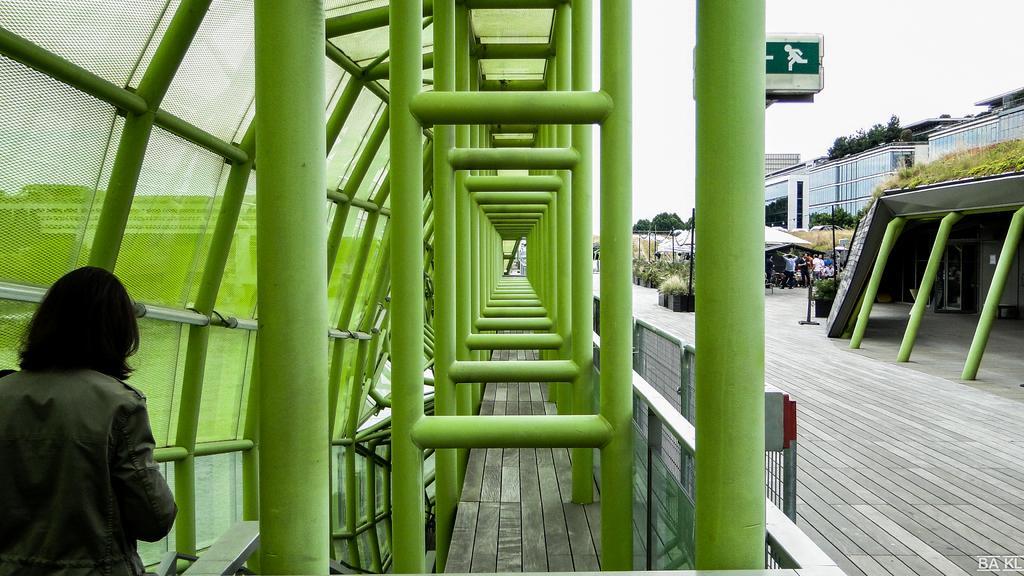Could you give a brief overview of what you see in this image? In this image we can see few metal rods, a person standing near the fence, there is railing, few plants, people standing on the floor, few trees, buildings and the sky in the background. 